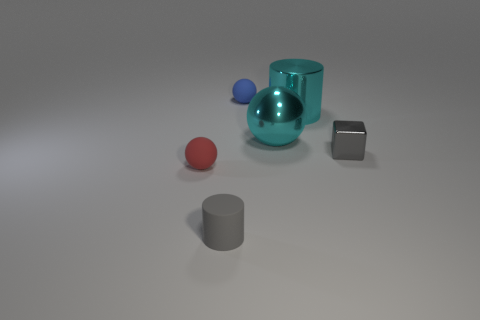There is a cylinder that is the same color as the small block; what is its material?
Offer a very short reply. Rubber. There is a ball on the left side of the tiny matte thing behind the metal cylinder; how big is it?
Give a very brief answer. Small. Is there a cyan cylinder that has the same material as the big sphere?
Make the answer very short. Yes. There is a gray cylinder that is the same size as the red thing; what is its material?
Your answer should be very brief. Rubber. Is the color of the tiny ball behind the gray block the same as the sphere that is on the left side of the tiny gray cylinder?
Your answer should be compact. No. Is there a cyan object in front of the rubber thing in front of the tiny red matte sphere?
Offer a very short reply. No. There is a rubber object behind the cube; is its shape the same as the big cyan thing behind the large cyan metallic ball?
Give a very brief answer. No. Is the material of the small sphere in front of the tiny gray shiny thing the same as the small sphere that is behind the gray metallic block?
Provide a short and direct response. Yes. What material is the sphere that is in front of the small thing that is right of the blue matte sphere?
Provide a succinct answer. Rubber. There is a small matte thing that is to the right of the small thing in front of the small matte ball in front of the small gray block; what is its shape?
Your answer should be very brief. Sphere. 